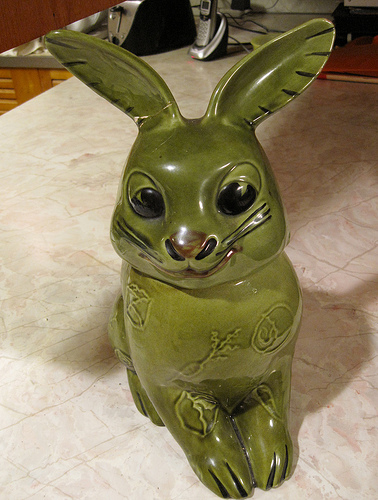<image>
Is there a rabbit on the table? Yes. Looking at the image, I can see the rabbit is positioned on top of the table, with the table providing support. 